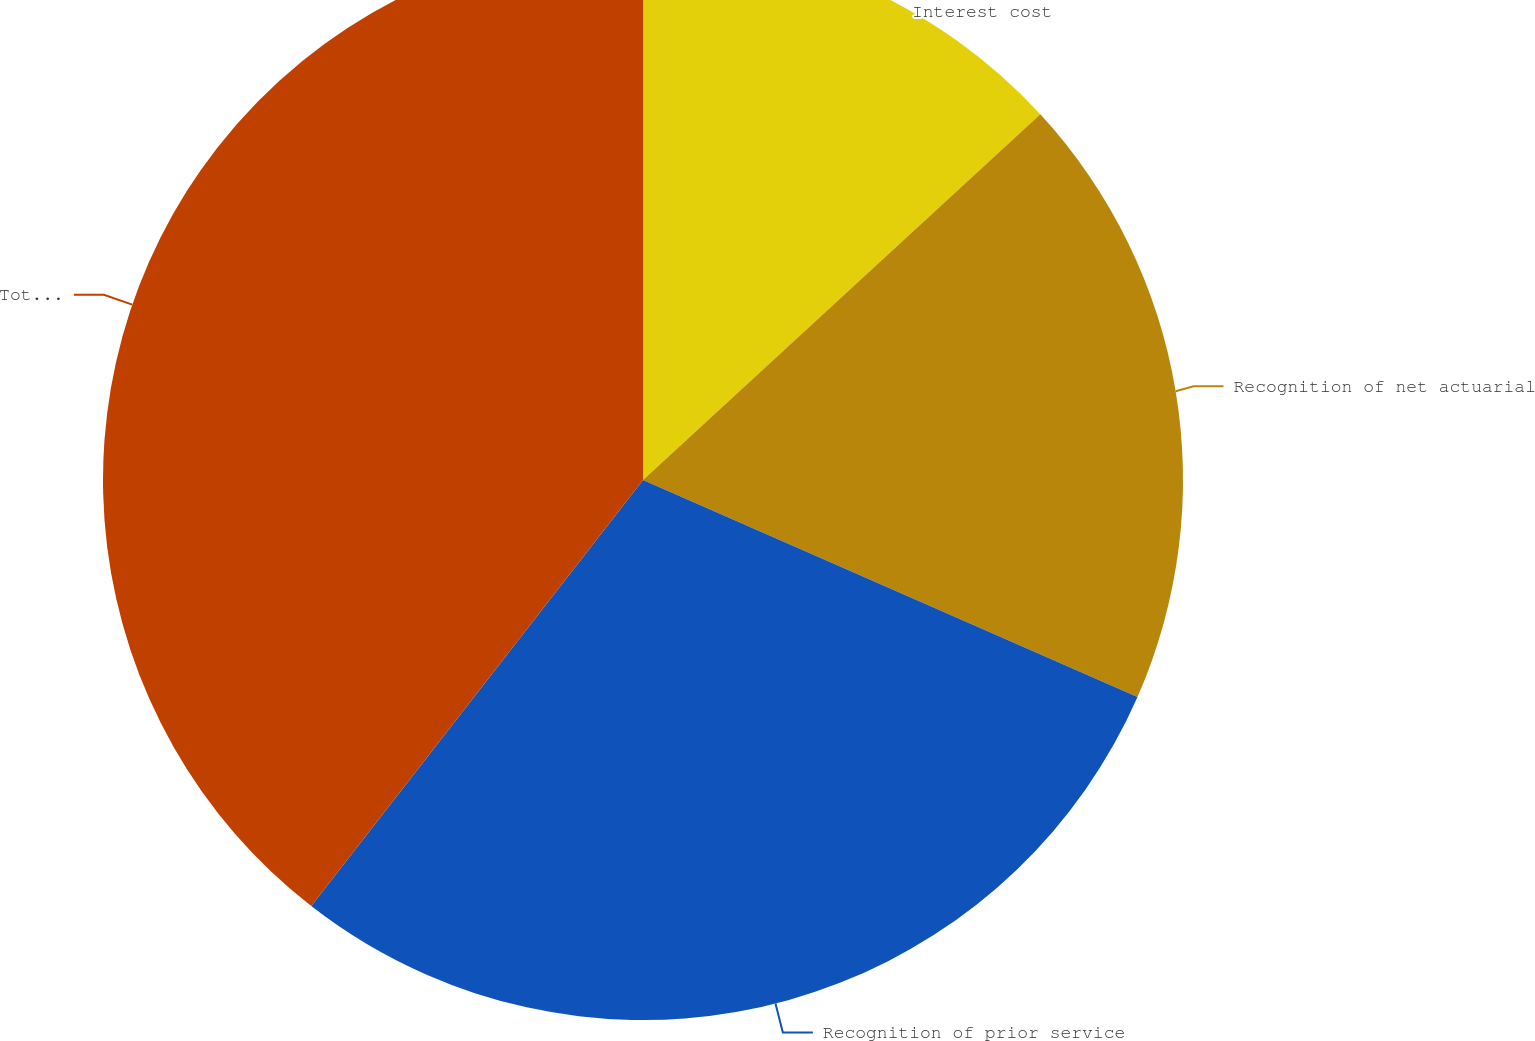Convert chart. <chart><loc_0><loc_0><loc_500><loc_500><pie_chart><fcel>Interest cost<fcel>Recognition of net actuarial<fcel>Recognition of prior service<fcel>Total other comprehensive loss<nl><fcel>13.16%<fcel>18.42%<fcel>28.95%<fcel>39.47%<nl></chart> 